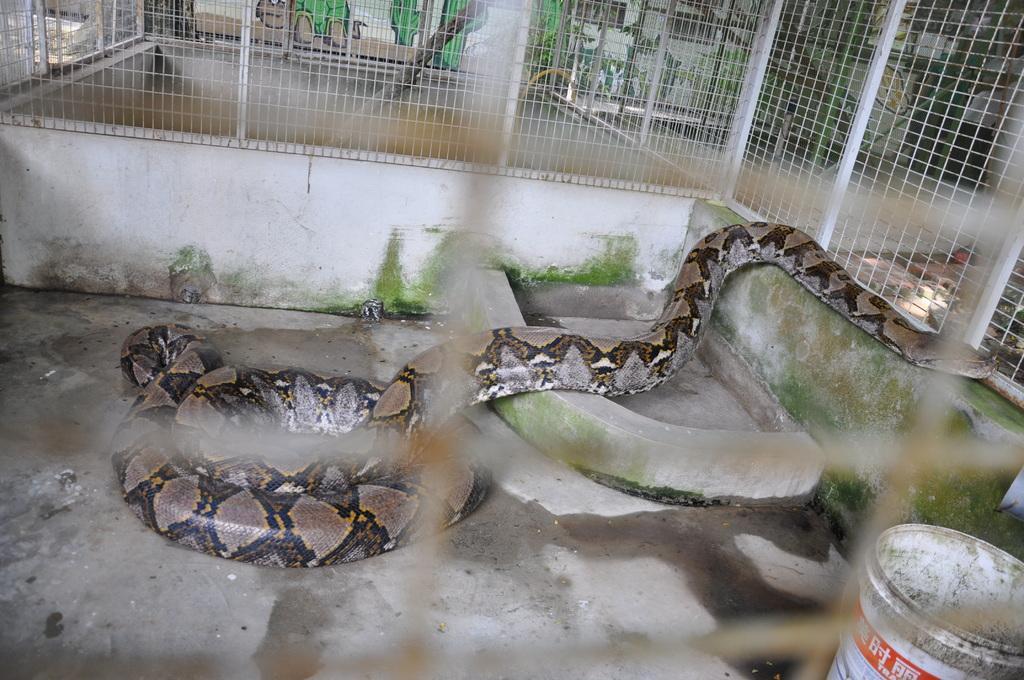Please provide a concise description of this image. This is the picture of a snake on a surface and we can see fence around it and to the side we can see a bucket. In the background, we can see the wall with some pictures on it. 